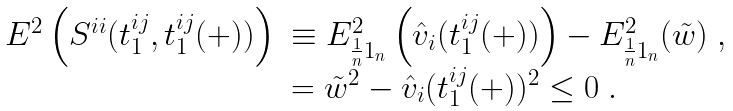<formula> <loc_0><loc_0><loc_500><loc_500>\begin{array} { l l l l } E ^ { 2 } \left ( S ^ { i i } ( t ^ { i j } _ { 1 } , t ^ { i j } _ { 1 } ( + ) ) \right ) & \equiv E _ { \frac { 1 } { n } 1 _ { n } } ^ { 2 } \left ( \hat { v } _ { i } ( t ^ { i j } _ { 1 } ( + ) ) \right ) - E _ { \frac { 1 } { n } 1 _ { n } } ^ { 2 } ( \tilde { w } ) \ , \\ & = \tilde { w } ^ { 2 } - \hat { v } _ { i } ( t ^ { i j } _ { 1 } ( + ) ) ^ { 2 } \leq 0 \ . \end{array}</formula> 